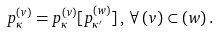Convert formula to latex. <formula><loc_0><loc_0><loc_500><loc_500>p _ { \kappa } ^ { ( v ) } = p _ { \kappa } ^ { ( v ) } [ p _ { \kappa ^ { \prime } } ^ { ( w ) } ] \, , \, \forall \, ( v ) \subset ( w ) \, .</formula> 